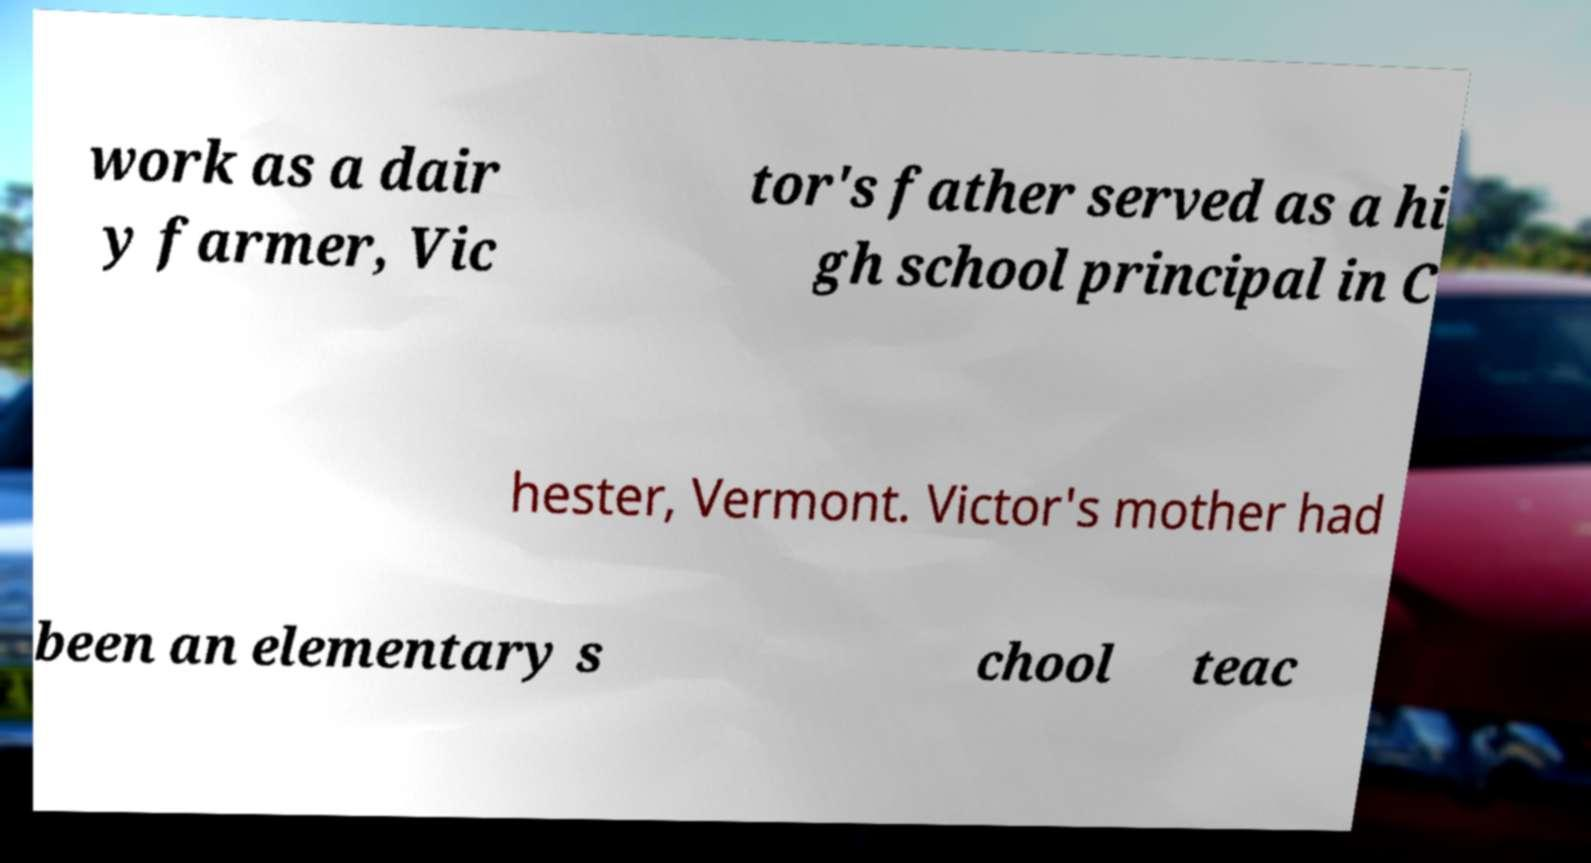There's text embedded in this image that I need extracted. Can you transcribe it verbatim? work as a dair y farmer, Vic tor's father served as a hi gh school principal in C hester, Vermont. Victor's mother had been an elementary s chool teac 